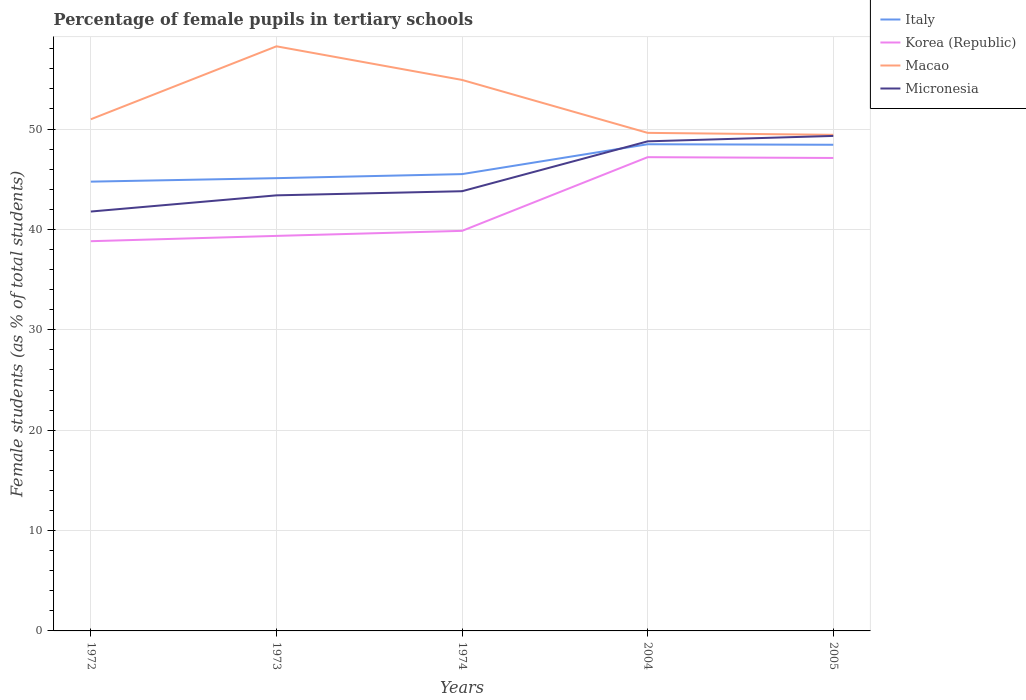How many different coloured lines are there?
Provide a short and direct response. 4. Is the number of lines equal to the number of legend labels?
Provide a succinct answer. Yes. Across all years, what is the maximum percentage of female pupils in tertiary schools in Korea (Republic)?
Keep it short and to the point. 38.83. In which year was the percentage of female pupils in tertiary schools in Micronesia maximum?
Provide a succinct answer. 1972. What is the total percentage of female pupils in tertiary schools in Micronesia in the graph?
Offer a very short reply. -4.97. What is the difference between the highest and the second highest percentage of female pupils in tertiary schools in Italy?
Provide a short and direct response. 3.72. What is the difference between the highest and the lowest percentage of female pupils in tertiary schools in Macao?
Provide a succinct answer. 2. Does the graph contain any zero values?
Your answer should be compact. No. Where does the legend appear in the graph?
Offer a very short reply. Top right. What is the title of the graph?
Give a very brief answer. Percentage of female pupils in tertiary schools. What is the label or title of the Y-axis?
Your answer should be compact. Female students (as % of total students). What is the Female students (as % of total students) in Italy in 1972?
Keep it short and to the point. 44.76. What is the Female students (as % of total students) of Korea (Republic) in 1972?
Make the answer very short. 38.83. What is the Female students (as % of total students) in Macao in 1972?
Ensure brevity in your answer.  50.98. What is the Female students (as % of total students) in Micronesia in 1972?
Provide a succinct answer. 41.78. What is the Female students (as % of total students) of Italy in 1973?
Your answer should be very brief. 45.11. What is the Female students (as % of total students) of Korea (Republic) in 1973?
Keep it short and to the point. 39.36. What is the Female students (as % of total students) in Macao in 1973?
Your answer should be compact. 58.24. What is the Female students (as % of total students) in Micronesia in 1973?
Offer a very short reply. 43.4. What is the Female students (as % of total students) of Italy in 1974?
Offer a terse response. 45.51. What is the Female students (as % of total students) of Korea (Republic) in 1974?
Keep it short and to the point. 39.86. What is the Female students (as % of total students) of Macao in 1974?
Your response must be concise. 54.9. What is the Female students (as % of total students) of Micronesia in 1974?
Your answer should be compact. 43.81. What is the Female students (as % of total students) in Italy in 2004?
Make the answer very short. 48.49. What is the Female students (as % of total students) in Korea (Republic) in 2004?
Provide a short and direct response. 47.2. What is the Female students (as % of total students) of Macao in 2004?
Offer a terse response. 49.62. What is the Female students (as % of total students) in Micronesia in 2004?
Ensure brevity in your answer.  48.78. What is the Female students (as % of total students) of Italy in 2005?
Ensure brevity in your answer.  48.44. What is the Female students (as % of total students) of Korea (Republic) in 2005?
Keep it short and to the point. 47.12. What is the Female students (as % of total students) in Macao in 2005?
Keep it short and to the point. 49.43. What is the Female students (as % of total students) of Micronesia in 2005?
Make the answer very short. 49.32. Across all years, what is the maximum Female students (as % of total students) in Italy?
Give a very brief answer. 48.49. Across all years, what is the maximum Female students (as % of total students) in Korea (Republic)?
Ensure brevity in your answer.  47.2. Across all years, what is the maximum Female students (as % of total students) in Macao?
Give a very brief answer. 58.24. Across all years, what is the maximum Female students (as % of total students) of Micronesia?
Make the answer very short. 49.32. Across all years, what is the minimum Female students (as % of total students) in Italy?
Provide a succinct answer. 44.76. Across all years, what is the minimum Female students (as % of total students) in Korea (Republic)?
Ensure brevity in your answer.  38.83. Across all years, what is the minimum Female students (as % of total students) of Macao?
Make the answer very short. 49.43. Across all years, what is the minimum Female students (as % of total students) in Micronesia?
Give a very brief answer. 41.78. What is the total Female students (as % of total students) of Italy in the graph?
Provide a short and direct response. 232.31. What is the total Female students (as % of total students) in Korea (Republic) in the graph?
Your answer should be very brief. 212.37. What is the total Female students (as % of total students) in Macao in the graph?
Your answer should be compact. 263.17. What is the total Female students (as % of total students) of Micronesia in the graph?
Offer a very short reply. 227.09. What is the difference between the Female students (as % of total students) of Italy in 1972 and that in 1973?
Provide a succinct answer. -0.35. What is the difference between the Female students (as % of total students) of Korea (Republic) in 1972 and that in 1973?
Keep it short and to the point. -0.53. What is the difference between the Female students (as % of total students) in Macao in 1972 and that in 1973?
Provide a succinct answer. -7.27. What is the difference between the Female students (as % of total students) of Micronesia in 1972 and that in 1973?
Ensure brevity in your answer.  -1.61. What is the difference between the Female students (as % of total students) in Italy in 1972 and that in 1974?
Your answer should be very brief. -0.75. What is the difference between the Female students (as % of total students) in Korea (Republic) in 1972 and that in 1974?
Give a very brief answer. -1.03. What is the difference between the Female students (as % of total students) in Macao in 1972 and that in 1974?
Your answer should be compact. -3.92. What is the difference between the Female students (as % of total students) of Micronesia in 1972 and that in 1974?
Ensure brevity in your answer.  -2.02. What is the difference between the Female students (as % of total students) in Italy in 1972 and that in 2004?
Make the answer very short. -3.72. What is the difference between the Female students (as % of total students) of Korea (Republic) in 1972 and that in 2004?
Provide a succinct answer. -8.37. What is the difference between the Female students (as % of total students) of Macao in 1972 and that in 2004?
Your response must be concise. 1.36. What is the difference between the Female students (as % of total students) of Micronesia in 1972 and that in 2004?
Ensure brevity in your answer.  -6.99. What is the difference between the Female students (as % of total students) of Italy in 1972 and that in 2005?
Your answer should be very brief. -3.67. What is the difference between the Female students (as % of total students) in Korea (Republic) in 1972 and that in 2005?
Ensure brevity in your answer.  -8.29. What is the difference between the Female students (as % of total students) in Macao in 1972 and that in 2005?
Keep it short and to the point. 1.55. What is the difference between the Female students (as % of total students) of Micronesia in 1972 and that in 2005?
Offer a very short reply. -7.53. What is the difference between the Female students (as % of total students) in Italy in 1973 and that in 1974?
Offer a very short reply. -0.4. What is the difference between the Female students (as % of total students) in Korea (Republic) in 1973 and that in 1974?
Offer a terse response. -0.5. What is the difference between the Female students (as % of total students) in Macao in 1973 and that in 1974?
Your response must be concise. 3.35. What is the difference between the Female students (as % of total students) in Micronesia in 1973 and that in 1974?
Keep it short and to the point. -0.41. What is the difference between the Female students (as % of total students) in Italy in 1973 and that in 2004?
Give a very brief answer. -3.38. What is the difference between the Female students (as % of total students) of Korea (Republic) in 1973 and that in 2004?
Offer a very short reply. -7.84. What is the difference between the Female students (as % of total students) of Macao in 1973 and that in 2004?
Provide a succinct answer. 8.62. What is the difference between the Female students (as % of total students) of Micronesia in 1973 and that in 2004?
Give a very brief answer. -5.38. What is the difference between the Female students (as % of total students) of Italy in 1973 and that in 2005?
Your response must be concise. -3.33. What is the difference between the Female students (as % of total students) in Korea (Republic) in 1973 and that in 2005?
Give a very brief answer. -7.76. What is the difference between the Female students (as % of total students) in Macao in 1973 and that in 2005?
Provide a short and direct response. 8.82. What is the difference between the Female students (as % of total students) of Micronesia in 1973 and that in 2005?
Your answer should be very brief. -5.92. What is the difference between the Female students (as % of total students) of Italy in 1974 and that in 2004?
Your answer should be very brief. -2.97. What is the difference between the Female students (as % of total students) in Korea (Republic) in 1974 and that in 2004?
Offer a terse response. -7.34. What is the difference between the Female students (as % of total students) of Macao in 1974 and that in 2004?
Provide a short and direct response. 5.27. What is the difference between the Female students (as % of total students) in Micronesia in 1974 and that in 2004?
Give a very brief answer. -4.97. What is the difference between the Female students (as % of total students) in Italy in 1974 and that in 2005?
Provide a short and direct response. -2.92. What is the difference between the Female students (as % of total students) in Korea (Republic) in 1974 and that in 2005?
Your answer should be very brief. -7.26. What is the difference between the Female students (as % of total students) of Macao in 1974 and that in 2005?
Give a very brief answer. 5.47. What is the difference between the Female students (as % of total students) of Micronesia in 1974 and that in 2005?
Ensure brevity in your answer.  -5.51. What is the difference between the Female students (as % of total students) of Italy in 2004 and that in 2005?
Your response must be concise. 0.05. What is the difference between the Female students (as % of total students) of Korea (Republic) in 2004 and that in 2005?
Give a very brief answer. 0.08. What is the difference between the Female students (as % of total students) of Macao in 2004 and that in 2005?
Provide a succinct answer. 0.2. What is the difference between the Female students (as % of total students) of Micronesia in 2004 and that in 2005?
Give a very brief answer. -0.54. What is the difference between the Female students (as % of total students) of Italy in 1972 and the Female students (as % of total students) of Korea (Republic) in 1973?
Provide a short and direct response. 5.41. What is the difference between the Female students (as % of total students) of Italy in 1972 and the Female students (as % of total students) of Macao in 1973?
Your answer should be compact. -13.48. What is the difference between the Female students (as % of total students) in Italy in 1972 and the Female students (as % of total students) in Micronesia in 1973?
Your answer should be very brief. 1.37. What is the difference between the Female students (as % of total students) in Korea (Republic) in 1972 and the Female students (as % of total students) in Macao in 1973?
Your response must be concise. -19.42. What is the difference between the Female students (as % of total students) in Korea (Republic) in 1972 and the Female students (as % of total students) in Micronesia in 1973?
Your response must be concise. -4.57. What is the difference between the Female students (as % of total students) of Macao in 1972 and the Female students (as % of total students) of Micronesia in 1973?
Provide a succinct answer. 7.58. What is the difference between the Female students (as % of total students) of Italy in 1972 and the Female students (as % of total students) of Korea (Republic) in 1974?
Your answer should be very brief. 4.9. What is the difference between the Female students (as % of total students) in Italy in 1972 and the Female students (as % of total students) in Macao in 1974?
Your response must be concise. -10.13. What is the difference between the Female students (as % of total students) in Italy in 1972 and the Female students (as % of total students) in Micronesia in 1974?
Give a very brief answer. 0.96. What is the difference between the Female students (as % of total students) of Korea (Republic) in 1972 and the Female students (as % of total students) of Macao in 1974?
Keep it short and to the point. -16.07. What is the difference between the Female students (as % of total students) of Korea (Republic) in 1972 and the Female students (as % of total students) of Micronesia in 1974?
Give a very brief answer. -4.98. What is the difference between the Female students (as % of total students) of Macao in 1972 and the Female students (as % of total students) of Micronesia in 1974?
Provide a short and direct response. 7.17. What is the difference between the Female students (as % of total students) of Italy in 1972 and the Female students (as % of total students) of Korea (Republic) in 2004?
Keep it short and to the point. -2.44. What is the difference between the Female students (as % of total students) in Italy in 1972 and the Female students (as % of total students) in Macao in 2004?
Give a very brief answer. -4.86. What is the difference between the Female students (as % of total students) in Italy in 1972 and the Female students (as % of total students) in Micronesia in 2004?
Ensure brevity in your answer.  -4.01. What is the difference between the Female students (as % of total students) of Korea (Republic) in 1972 and the Female students (as % of total students) of Macao in 2004?
Offer a very short reply. -10.79. What is the difference between the Female students (as % of total students) of Korea (Republic) in 1972 and the Female students (as % of total students) of Micronesia in 2004?
Your answer should be compact. -9.95. What is the difference between the Female students (as % of total students) of Macao in 1972 and the Female students (as % of total students) of Micronesia in 2004?
Make the answer very short. 2.2. What is the difference between the Female students (as % of total students) of Italy in 1972 and the Female students (as % of total students) of Korea (Republic) in 2005?
Offer a terse response. -2.36. What is the difference between the Female students (as % of total students) of Italy in 1972 and the Female students (as % of total students) of Macao in 2005?
Offer a terse response. -4.66. What is the difference between the Female students (as % of total students) of Italy in 1972 and the Female students (as % of total students) of Micronesia in 2005?
Offer a terse response. -4.55. What is the difference between the Female students (as % of total students) of Korea (Republic) in 1972 and the Female students (as % of total students) of Macao in 2005?
Your response must be concise. -10.6. What is the difference between the Female students (as % of total students) of Korea (Republic) in 1972 and the Female students (as % of total students) of Micronesia in 2005?
Offer a very short reply. -10.49. What is the difference between the Female students (as % of total students) in Macao in 1972 and the Female students (as % of total students) in Micronesia in 2005?
Provide a short and direct response. 1.66. What is the difference between the Female students (as % of total students) in Italy in 1973 and the Female students (as % of total students) in Korea (Republic) in 1974?
Your answer should be very brief. 5.25. What is the difference between the Female students (as % of total students) in Italy in 1973 and the Female students (as % of total students) in Macao in 1974?
Provide a short and direct response. -9.79. What is the difference between the Female students (as % of total students) in Italy in 1973 and the Female students (as % of total students) in Micronesia in 1974?
Your answer should be compact. 1.3. What is the difference between the Female students (as % of total students) in Korea (Republic) in 1973 and the Female students (as % of total students) in Macao in 1974?
Give a very brief answer. -15.54. What is the difference between the Female students (as % of total students) of Korea (Republic) in 1973 and the Female students (as % of total students) of Micronesia in 1974?
Your answer should be compact. -4.45. What is the difference between the Female students (as % of total students) in Macao in 1973 and the Female students (as % of total students) in Micronesia in 1974?
Make the answer very short. 14.44. What is the difference between the Female students (as % of total students) of Italy in 1973 and the Female students (as % of total students) of Korea (Republic) in 2004?
Give a very brief answer. -2.09. What is the difference between the Female students (as % of total students) of Italy in 1973 and the Female students (as % of total students) of Macao in 2004?
Your response must be concise. -4.51. What is the difference between the Female students (as % of total students) in Italy in 1973 and the Female students (as % of total students) in Micronesia in 2004?
Make the answer very short. -3.67. What is the difference between the Female students (as % of total students) in Korea (Republic) in 1973 and the Female students (as % of total students) in Macao in 2004?
Offer a very short reply. -10.27. What is the difference between the Female students (as % of total students) in Korea (Republic) in 1973 and the Female students (as % of total students) in Micronesia in 2004?
Your answer should be very brief. -9.42. What is the difference between the Female students (as % of total students) of Macao in 1973 and the Female students (as % of total students) of Micronesia in 2004?
Your response must be concise. 9.47. What is the difference between the Female students (as % of total students) in Italy in 1973 and the Female students (as % of total students) in Korea (Republic) in 2005?
Your answer should be compact. -2.01. What is the difference between the Female students (as % of total students) of Italy in 1973 and the Female students (as % of total students) of Macao in 2005?
Your answer should be compact. -4.32. What is the difference between the Female students (as % of total students) in Italy in 1973 and the Female students (as % of total students) in Micronesia in 2005?
Provide a succinct answer. -4.21. What is the difference between the Female students (as % of total students) in Korea (Republic) in 1973 and the Female students (as % of total students) in Macao in 2005?
Your response must be concise. -10.07. What is the difference between the Female students (as % of total students) in Korea (Republic) in 1973 and the Female students (as % of total students) in Micronesia in 2005?
Give a very brief answer. -9.96. What is the difference between the Female students (as % of total students) in Macao in 1973 and the Female students (as % of total students) in Micronesia in 2005?
Provide a succinct answer. 8.93. What is the difference between the Female students (as % of total students) in Italy in 1974 and the Female students (as % of total students) in Korea (Republic) in 2004?
Provide a short and direct response. -1.69. What is the difference between the Female students (as % of total students) of Italy in 1974 and the Female students (as % of total students) of Macao in 2004?
Make the answer very short. -4.11. What is the difference between the Female students (as % of total students) of Italy in 1974 and the Female students (as % of total students) of Micronesia in 2004?
Offer a terse response. -3.27. What is the difference between the Female students (as % of total students) in Korea (Republic) in 1974 and the Female students (as % of total students) in Macao in 2004?
Provide a short and direct response. -9.76. What is the difference between the Female students (as % of total students) of Korea (Republic) in 1974 and the Female students (as % of total students) of Micronesia in 2004?
Provide a succinct answer. -8.92. What is the difference between the Female students (as % of total students) in Macao in 1974 and the Female students (as % of total students) in Micronesia in 2004?
Offer a terse response. 6.12. What is the difference between the Female students (as % of total students) in Italy in 1974 and the Female students (as % of total students) in Korea (Republic) in 2005?
Give a very brief answer. -1.61. What is the difference between the Female students (as % of total students) in Italy in 1974 and the Female students (as % of total students) in Macao in 2005?
Your response must be concise. -3.91. What is the difference between the Female students (as % of total students) in Italy in 1974 and the Female students (as % of total students) in Micronesia in 2005?
Make the answer very short. -3.8. What is the difference between the Female students (as % of total students) of Korea (Republic) in 1974 and the Female students (as % of total students) of Macao in 2005?
Your response must be concise. -9.57. What is the difference between the Female students (as % of total students) in Korea (Republic) in 1974 and the Female students (as % of total students) in Micronesia in 2005?
Offer a terse response. -9.46. What is the difference between the Female students (as % of total students) in Macao in 1974 and the Female students (as % of total students) in Micronesia in 2005?
Keep it short and to the point. 5.58. What is the difference between the Female students (as % of total students) of Italy in 2004 and the Female students (as % of total students) of Korea (Republic) in 2005?
Provide a short and direct response. 1.37. What is the difference between the Female students (as % of total students) in Italy in 2004 and the Female students (as % of total students) in Macao in 2005?
Provide a short and direct response. -0.94. What is the difference between the Female students (as % of total students) in Italy in 2004 and the Female students (as % of total students) in Micronesia in 2005?
Offer a very short reply. -0.83. What is the difference between the Female students (as % of total students) in Korea (Republic) in 2004 and the Female students (as % of total students) in Macao in 2005?
Your response must be concise. -2.23. What is the difference between the Female students (as % of total students) in Korea (Republic) in 2004 and the Female students (as % of total students) in Micronesia in 2005?
Your answer should be compact. -2.12. What is the difference between the Female students (as % of total students) of Macao in 2004 and the Female students (as % of total students) of Micronesia in 2005?
Provide a short and direct response. 0.3. What is the average Female students (as % of total students) of Italy per year?
Make the answer very short. 46.46. What is the average Female students (as % of total students) of Korea (Republic) per year?
Offer a very short reply. 42.47. What is the average Female students (as % of total students) in Macao per year?
Your answer should be compact. 52.63. What is the average Female students (as % of total students) of Micronesia per year?
Your answer should be compact. 45.42. In the year 1972, what is the difference between the Female students (as % of total students) of Italy and Female students (as % of total students) of Korea (Republic)?
Offer a very short reply. 5.94. In the year 1972, what is the difference between the Female students (as % of total students) of Italy and Female students (as % of total students) of Macao?
Ensure brevity in your answer.  -6.22. In the year 1972, what is the difference between the Female students (as % of total students) of Italy and Female students (as % of total students) of Micronesia?
Offer a very short reply. 2.98. In the year 1972, what is the difference between the Female students (as % of total students) of Korea (Republic) and Female students (as % of total students) of Macao?
Ensure brevity in your answer.  -12.15. In the year 1972, what is the difference between the Female students (as % of total students) in Korea (Republic) and Female students (as % of total students) in Micronesia?
Give a very brief answer. -2.96. In the year 1972, what is the difference between the Female students (as % of total students) of Macao and Female students (as % of total students) of Micronesia?
Your answer should be compact. 9.19. In the year 1973, what is the difference between the Female students (as % of total students) of Italy and Female students (as % of total students) of Korea (Republic)?
Make the answer very short. 5.75. In the year 1973, what is the difference between the Female students (as % of total students) in Italy and Female students (as % of total students) in Macao?
Provide a short and direct response. -13.14. In the year 1973, what is the difference between the Female students (as % of total students) of Italy and Female students (as % of total students) of Micronesia?
Your answer should be compact. 1.71. In the year 1973, what is the difference between the Female students (as % of total students) in Korea (Republic) and Female students (as % of total students) in Macao?
Your answer should be very brief. -18.89. In the year 1973, what is the difference between the Female students (as % of total students) of Korea (Republic) and Female students (as % of total students) of Micronesia?
Provide a short and direct response. -4.04. In the year 1973, what is the difference between the Female students (as % of total students) in Macao and Female students (as % of total students) in Micronesia?
Your answer should be very brief. 14.85. In the year 1974, what is the difference between the Female students (as % of total students) in Italy and Female students (as % of total students) in Korea (Republic)?
Give a very brief answer. 5.66. In the year 1974, what is the difference between the Female students (as % of total students) of Italy and Female students (as % of total students) of Macao?
Provide a short and direct response. -9.38. In the year 1974, what is the difference between the Female students (as % of total students) in Italy and Female students (as % of total students) in Micronesia?
Your answer should be very brief. 1.71. In the year 1974, what is the difference between the Female students (as % of total students) in Korea (Republic) and Female students (as % of total students) in Macao?
Your answer should be compact. -15.04. In the year 1974, what is the difference between the Female students (as % of total students) of Korea (Republic) and Female students (as % of total students) of Micronesia?
Provide a succinct answer. -3.95. In the year 1974, what is the difference between the Female students (as % of total students) in Macao and Female students (as % of total students) in Micronesia?
Your answer should be very brief. 11.09. In the year 2004, what is the difference between the Female students (as % of total students) of Italy and Female students (as % of total students) of Korea (Republic)?
Your response must be concise. 1.29. In the year 2004, what is the difference between the Female students (as % of total students) of Italy and Female students (as % of total students) of Macao?
Provide a succinct answer. -1.13. In the year 2004, what is the difference between the Female students (as % of total students) of Italy and Female students (as % of total students) of Micronesia?
Provide a short and direct response. -0.29. In the year 2004, what is the difference between the Female students (as % of total students) in Korea (Republic) and Female students (as % of total students) in Macao?
Make the answer very short. -2.42. In the year 2004, what is the difference between the Female students (as % of total students) of Korea (Republic) and Female students (as % of total students) of Micronesia?
Ensure brevity in your answer.  -1.58. In the year 2004, what is the difference between the Female students (as % of total students) of Macao and Female students (as % of total students) of Micronesia?
Provide a short and direct response. 0.84. In the year 2005, what is the difference between the Female students (as % of total students) in Italy and Female students (as % of total students) in Korea (Republic)?
Your answer should be compact. 1.31. In the year 2005, what is the difference between the Female students (as % of total students) of Italy and Female students (as % of total students) of Macao?
Give a very brief answer. -0.99. In the year 2005, what is the difference between the Female students (as % of total students) of Italy and Female students (as % of total students) of Micronesia?
Provide a short and direct response. -0.88. In the year 2005, what is the difference between the Female students (as % of total students) of Korea (Republic) and Female students (as % of total students) of Macao?
Provide a succinct answer. -2.31. In the year 2005, what is the difference between the Female students (as % of total students) of Korea (Republic) and Female students (as % of total students) of Micronesia?
Ensure brevity in your answer.  -2.2. In the year 2005, what is the difference between the Female students (as % of total students) in Macao and Female students (as % of total students) in Micronesia?
Provide a succinct answer. 0.11. What is the ratio of the Female students (as % of total students) in Korea (Republic) in 1972 to that in 1973?
Offer a very short reply. 0.99. What is the ratio of the Female students (as % of total students) of Macao in 1972 to that in 1973?
Make the answer very short. 0.88. What is the ratio of the Female students (as % of total students) in Micronesia in 1972 to that in 1973?
Give a very brief answer. 0.96. What is the ratio of the Female students (as % of total students) in Italy in 1972 to that in 1974?
Your answer should be very brief. 0.98. What is the ratio of the Female students (as % of total students) in Korea (Republic) in 1972 to that in 1974?
Offer a terse response. 0.97. What is the ratio of the Female students (as % of total students) of Micronesia in 1972 to that in 1974?
Keep it short and to the point. 0.95. What is the ratio of the Female students (as % of total students) in Italy in 1972 to that in 2004?
Offer a terse response. 0.92. What is the ratio of the Female students (as % of total students) of Korea (Republic) in 1972 to that in 2004?
Offer a very short reply. 0.82. What is the ratio of the Female students (as % of total students) in Macao in 1972 to that in 2004?
Your response must be concise. 1.03. What is the ratio of the Female students (as % of total students) in Micronesia in 1972 to that in 2004?
Provide a succinct answer. 0.86. What is the ratio of the Female students (as % of total students) in Italy in 1972 to that in 2005?
Your response must be concise. 0.92. What is the ratio of the Female students (as % of total students) in Korea (Republic) in 1972 to that in 2005?
Provide a short and direct response. 0.82. What is the ratio of the Female students (as % of total students) of Macao in 1972 to that in 2005?
Offer a very short reply. 1.03. What is the ratio of the Female students (as % of total students) of Micronesia in 1972 to that in 2005?
Offer a terse response. 0.85. What is the ratio of the Female students (as % of total students) of Korea (Republic) in 1973 to that in 1974?
Provide a succinct answer. 0.99. What is the ratio of the Female students (as % of total students) in Macao in 1973 to that in 1974?
Give a very brief answer. 1.06. What is the ratio of the Female students (as % of total students) of Micronesia in 1973 to that in 1974?
Your answer should be compact. 0.99. What is the ratio of the Female students (as % of total students) of Italy in 1973 to that in 2004?
Give a very brief answer. 0.93. What is the ratio of the Female students (as % of total students) of Korea (Republic) in 1973 to that in 2004?
Give a very brief answer. 0.83. What is the ratio of the Female students (as % of total students) of Macao in 1973 to that in 2004?
Offer a very short reply. 1.17. What is the ratio of the Female students (as % of total students) of Micronesia in 1973 to that in 2004?
Provide a succinct answer. 0.89. What is the ratio of the Female students (as % of total students) of Italy in 1973 to that in 2005?
Make the answer very short. 0.93. What is the ratio of the Female students (as % of total students) of Korea (Republic) in 1973 to that in 2005?
Make the answer very short. 0.84. What is the ratio of the Female students (as % of total students) of Macao in 1973 to that in 2005?
Ensure brevity in your answer.  1.18. What is the ratio of the Female students (as % of total students) in Micronesia in 1973 to that in 2005?
Offer a terse response. 0.88. What is the ratio of the Female students (as % of total students) in Italy in 1974 to that in 2004?
Provide a succinct answer. 0.94. What is the ratio of the Female students (as % of total students) in Korea (Republic) in 1974 to that in 2004?
Offer a terse response. 0.84. What is the ratio of the Female students (as % of total students) in Macao in 1974 to that in 2004?
Make the answer very short. 1.11. What is the ratio of the Female students (as % of total students) in Micronesia in 1974 to that in 2004?
Ensure brevity in your answer.  0.9. What is the ratio of the Female students (as % of total students) in Italy in 1974 to that in 2005?
Give a very brief answer. 0.94. What is the ratio of the Female students (as % of total students) of Korea (Republic) in 1974 to that in 2005?
Offer a very short reply. 0.85. What is the ratio of the Female students (as % of total students) in Macao in 1974 to that in 2005?
Provide a succinct answer. 1.11. What is the ratio of the Female students (as % of total students) in Micronesia in 1974 to that in 2005?
Your answer should be very brief. 0.89. What is the ratio of the Female students (as % of total students) in Italy in 2004 to that in 2005?
Provide a short and direct response. 1. What is the ratio of the Female students (as % of total students) in Micronesia in 2004 to that in 2005?
Provide a succinct answer. 0.99. What is the difference between the highest and the second highest Female students (as % of total students) in Italy?
Keep it short and to the point. 0.05. What is the difference between the highest and the second highest Female students (as % of total students) of Korea (Republic)?
Offer a very short reply. 0.08. What is the difference between the highest and the second highest Female students (as % of total students) in Macao?
Give a very brief answer. 3.35. What is the difference between the highest and the second highest Female students (as % of total students) of Micronesia?
Offer a terse response. 0.54. What is the difference between the highest and the lowest Female students (as % of total students) in Italy?
Your answer should be compact. 3.72. What is the difference between the highest and the lowest Female students (as % of total students) of Korea (Republic)?
Offer a terse response. 8.37. What is the difference between the highest and the lowest Female students (as % of total students) in Macao?
Ensure brevity in your answer.  8.82. What is the difference between the highest and the lowest Female students (as % of total students) in Micronesia?
Your answer should be compact. 7.53. 